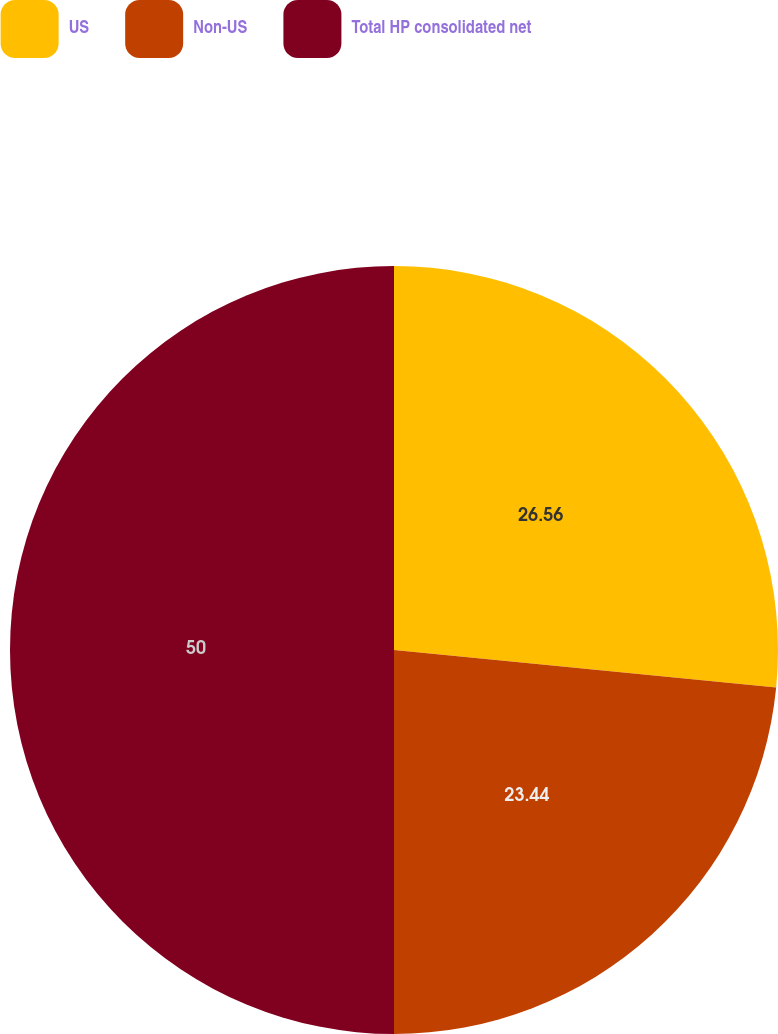<chart> <loc_0><loc_0><loc_500><loc_500><pie_chart><fcel>US<fcel>Non-US<fcel>Total HP consolidated net<nl><fcel>26.56%<fcel>23.44%<fcel>50.0%<nl></chart> 